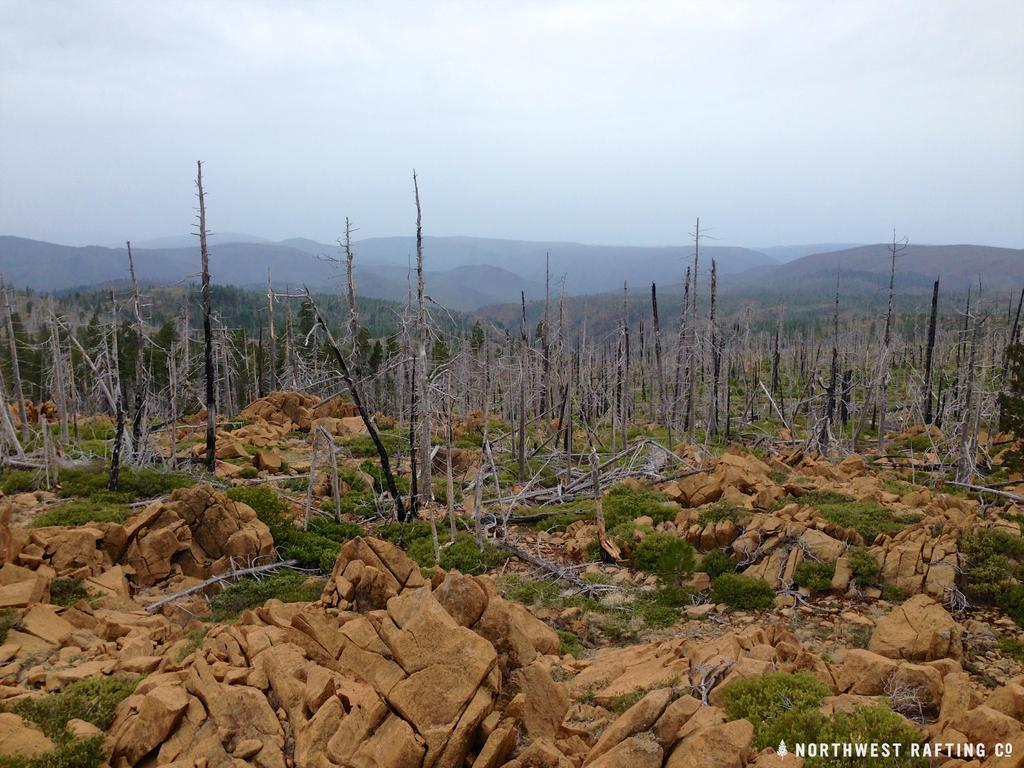What type of natural features can be seen on the ground in the image? There are rocks on the ground in the image. What type of vegetation is present in the image? There are shrubs and trees in the image. What type of elevated landforms can be seen in the image? There are hills in the image. What is visible in the sky in the image? The sky is visible in the image, and clouds are present. What type of drawer can be seen in the image? There is no drawer present in the image; it features natural landscapes with rocks, shrubs, trees, hills, sky, and clouds. 